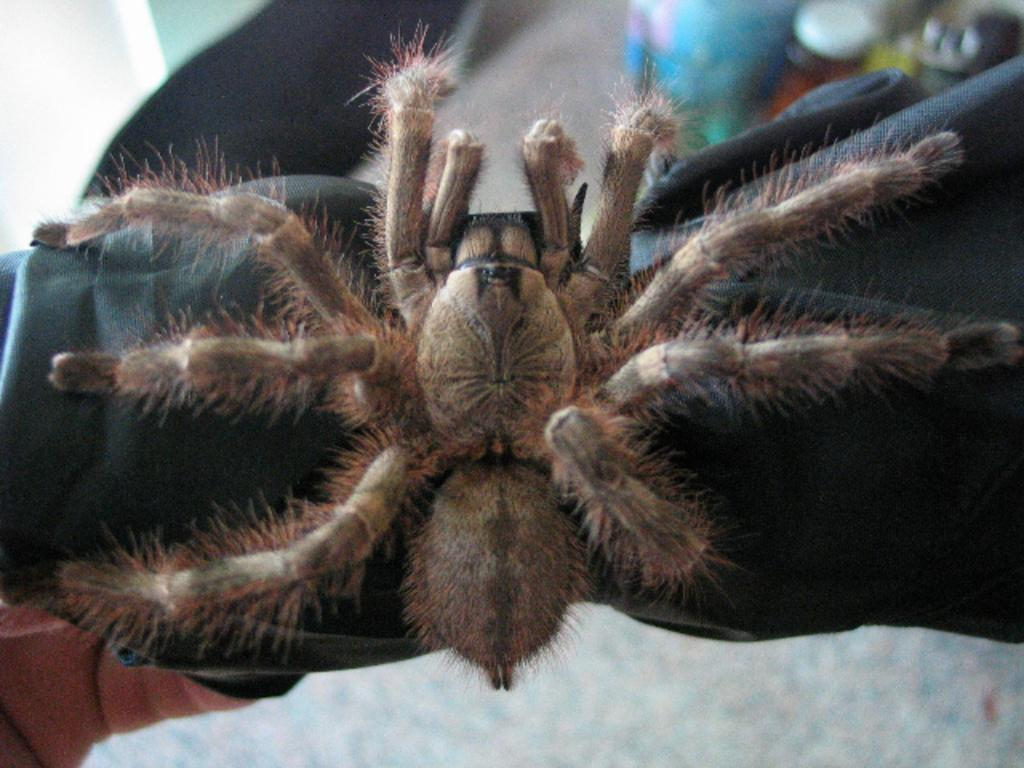What is the main subject of the image? There is a spider in the image. Where is the spider located? The spider is on a surface. What else can be seen in the background of the image? There is a bottle in the background of the image. What type of religious symbol can be seen near the spider in the image? There is no religious symbol present in the image; it only features a spider on a surface and a bottle in the background. 